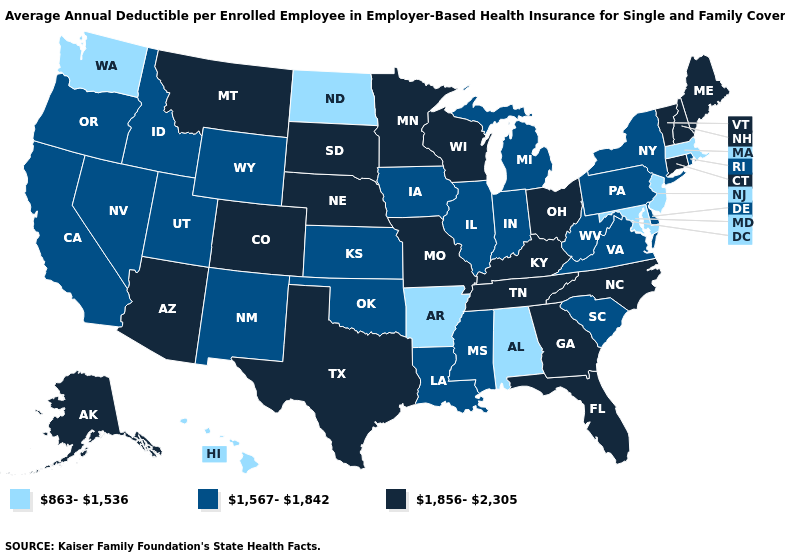Does Alabama have the lowest value in the USA?
Answer briefly. Yes. What is the highest value in the MidWest ?
Be succinct. 1,856-2,305. What is the value of Kentucky?
Short answer required. 1,856-2,305. What is the highest value in states that border Delaware?
Keep it brief. 1,567-1,842. What is the value of Washington?
Quick response, please. 863-1,536. What is the lowest value in the USA?
Short answer required. 863-1,536. What is the lowest value in the South?
Write a very short answer. 863-1,536. Does Texas have a lower value than Idaho?
Give a very brief answer. No. Is the legend a continuous bar?
Give a very brief answer. No. Does the first symbol in the legend represent the smallest category?
Concise answer only. Yes. What is the highest value in states that border Iowa?
Concise answer only. 1,856-2,305. Does the map have missing data?
Short answer required. No. What is the highest value in the Northeast ?
Quick response, please. 1,856-2,305. What is the lowest value in states that border North Carolina?
Concise answer only. 1,567-1,842. 